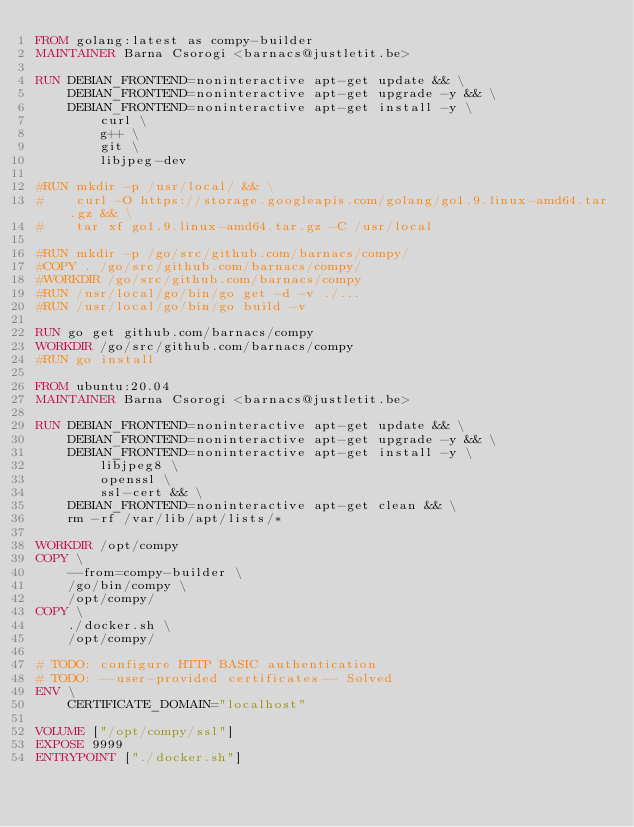Convert code to text. <code><loc_0><loc_0><loc_500><loc_500><_Dockerfile_>FROM golang:latest as compy-builder
MAINTAINER Barna Csorogi <barnacs@justletit.be>

RUN DEBIAN_FRONTEND=noninteractive apt-get update && \
    DEBIAN_FRONTEND=noninteractive apt-get upgrade -y && \
    DEBIAN_FRONTEND=noninteractive apt-get install -y \
        curl \
        g++ \
        git \
        libjpeg-dev

#RUN mkdir -p /usr/local/ && \
#    curl -O https://storage.googleapis.com/golang/go1.9.linux-amd64.tar.gz && \
#    tar xf go1.9.linux-amd64.tar.gz -C /usr/local

#RUN mkdir -p /go/src/github.com/barnacs/compy/
#COPY . /go/src/github.com/barnacs/compy/
#WORKDIR /go/src/github.com/barnacs/compy
#RUN /usr/local/go/bin/go get -d -v ./...
#RUN /usr/local/go/bin/go build -v

RUN go get github.com/barnacs/compy
WORKDIR /go/src/github.com/barnacs/compy
#RUN go install

FROM ubuntu:20.04
MAINTAINER Barna Csorogi <barnacs@justletit.be>

RUN DEBIAN_FRONTEND=noninteractive apt-get update && \
    DEBIAN_FRONTEND=noninteractive apt-get upgrade -y && \
    DEBIAN_FRONTEND=noninteractive apt-get install -y \
        libjpeg8 \
        openssl \
        ssl-cert && \
    DEBIAN_FRONTEND=noninteractive apt-get clean && \
    rm -rf /var/lib/apt/lists/*

WORKDIR /opt/compy
COPY \
    --from=compy-builder \
    /go/bin/compy \
    /opt/compy/
COPY \
    ./docker.sh \
    /opt/compy/
    
# TODO: configure HTTP BASIC authentication
# TODO: --user-provided certificates-- Solved
ENV \
    CERTIFICATE_DOMAIN="localhost"

VOLUME ["/opt/compy/ssl"]
EXPOSE 9999
ENTRYPOINT ["./docker.sh"]
</code> 